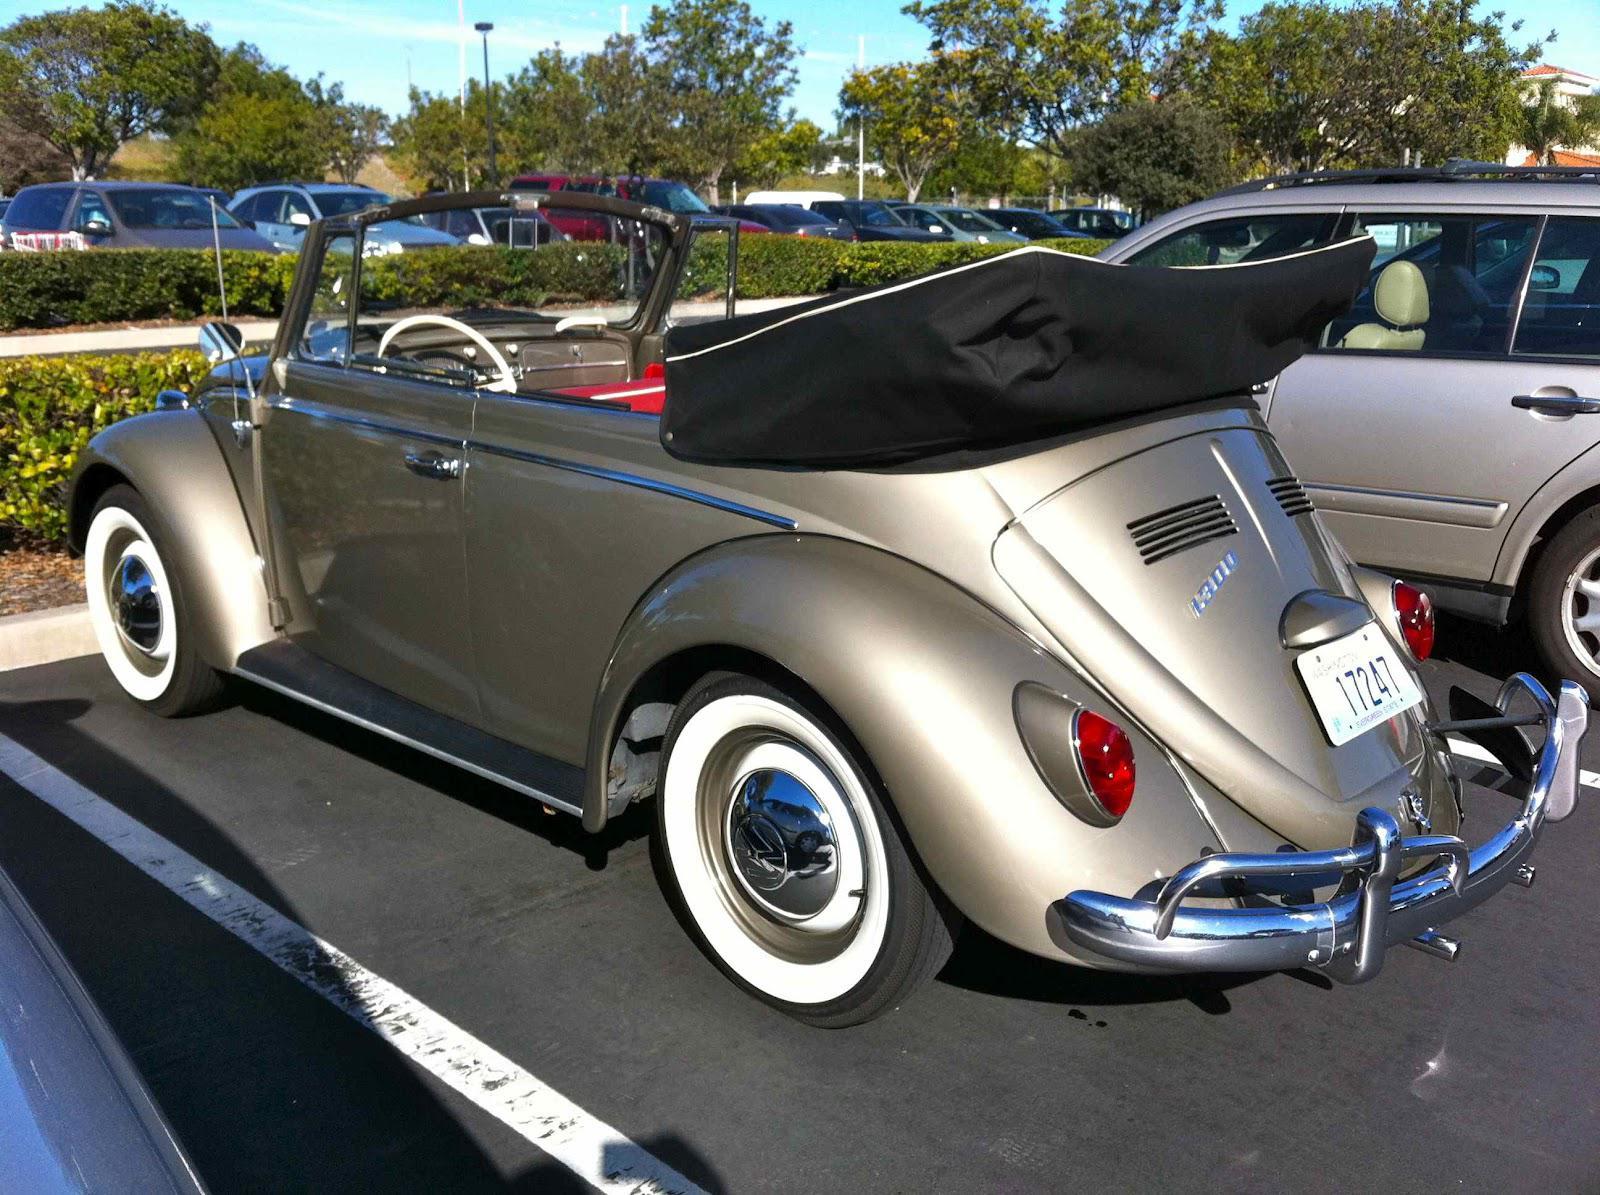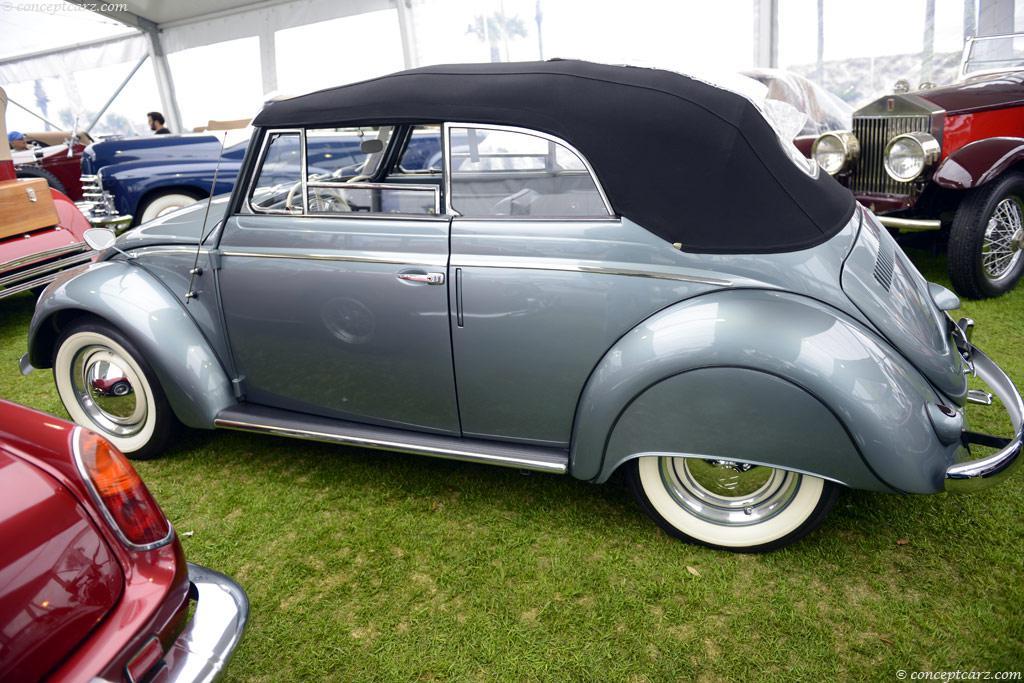The first image is the image on the left, the second image is the image on the right. Analyze the images presented: Is the assertion "One of the cars is parked entirely in grass." valid? Answer yes or no. Yes. The first image is the image on the left, the second image is the image on the right. For the images displayed, is the sentence "An image shows a non-white rear-facing convertible that is not parked on grass." factually correct? Answer yes or no. Yes. 